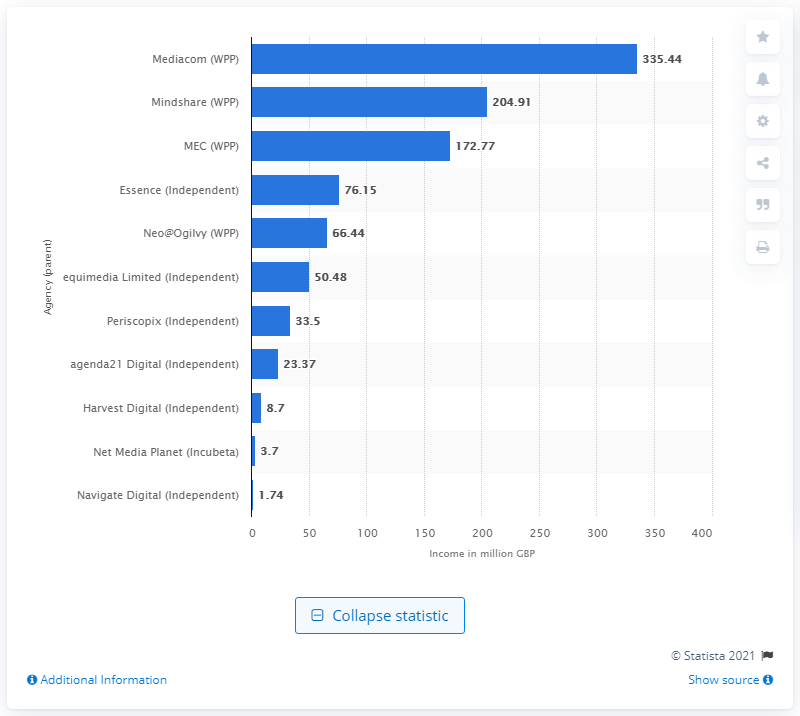Specify some key components in this picture. In 2014, MediaCom generated approximately 335.44 British pounds in income. 